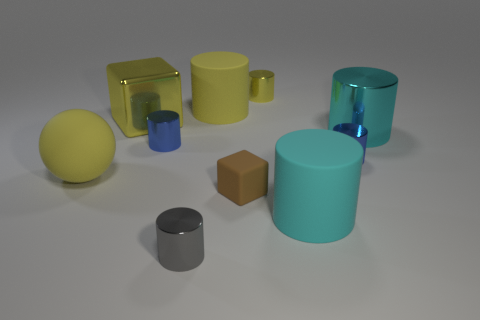Subtract all matte cylinders. How many cylinders are left? 5 Subtract all gray cylinders. How many cylinders are left? 6 Subtract all yellow rubber spheres. Subtract all small yellow shiny things. How many objects are left? 8 Add 8 big yellow matte objects. How many big yellow matte objects are left? 10 Add 1 shiny blocks. How many shiny blocks exist? 2 Subtract 0 green cylinders. How many objects are left? 10 Subtract all cylinders. How many objects are left? 3 Subtract 1 cubes. How many cubes are left? 1 Subtract all green cylinders. Subtract all purple balls. How many cylinders are left? 7 Subtract all cyan cylinders. How many yellow blocks are left? 1 